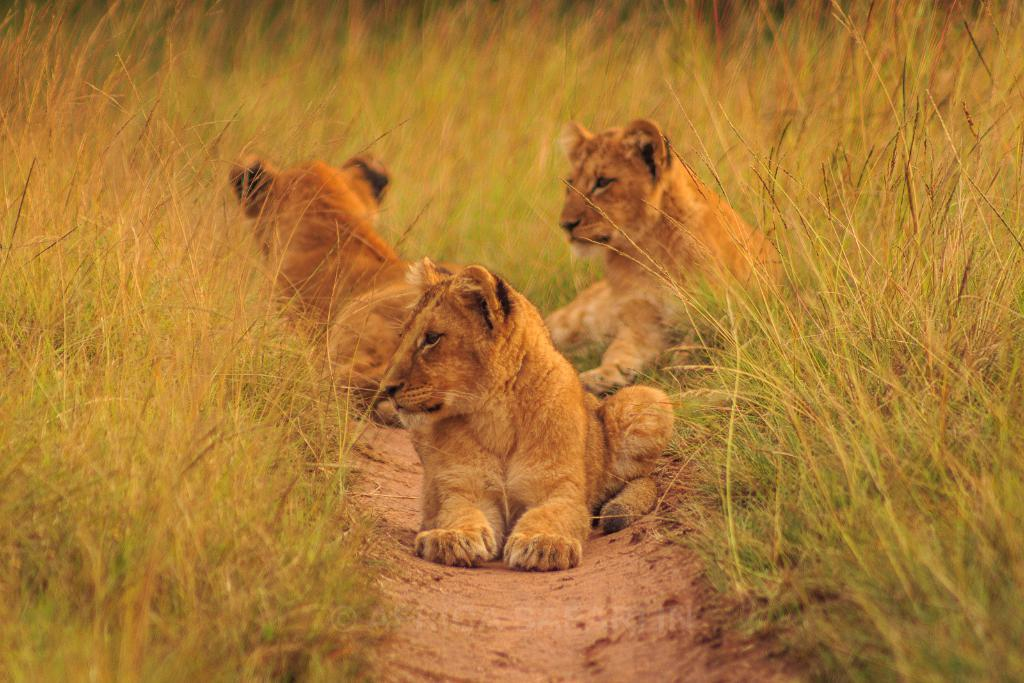What animals are present in the image? There are three cubs in the image. What is the cubs' position in relation to the ground? The cubs are sitting on the soil. What type of vegetation is visible around the cubs? There is grass around the cubs. What type of fruit can be seen growing on the trees in the image? There are no trees or fruit present in the image; it features three cubs sitting on the soil with grass around them. 